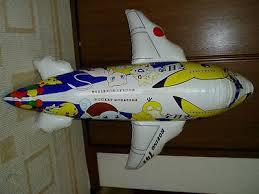Can you describe the colors and patterns on the airplane? The toy airplane features a combination of yellow, white, and blue colors. It includes fun, cartoon-ish patterns that add a playful and cheerful look. Does the design have any specific theme? Yes, the design includes elements that suggest a child-friendly theme, possibly incorporating characters or elements from popular children's animations, adding to its visual appeal for younger audiences. 